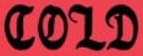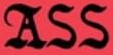Read the text content from these images in order, separated by a semicolon. COLD; ASS 